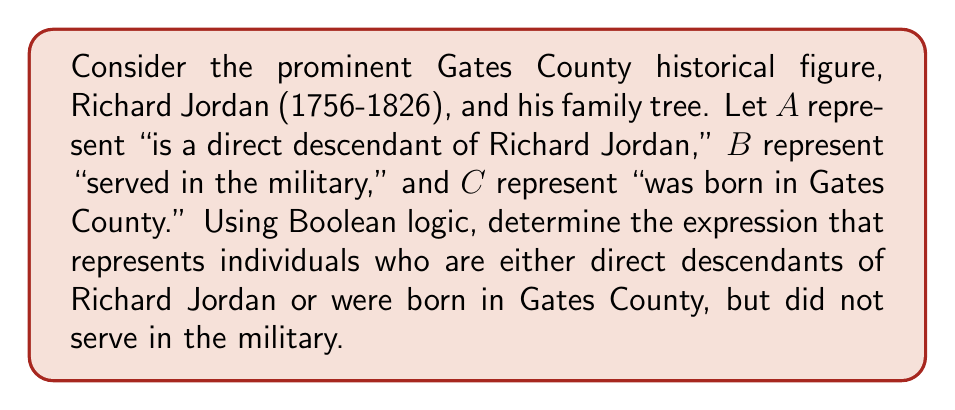What is the answer to this math problem? Let's approach this step-by-step using Boolean algebra:

1) First, we need to identify the basic propositions:
   A: is a direct descendant of Richard Jordan
   B: served in the military
   C: was born in Gates County

2) The question asks for individuals who are either direct descendants of Richard Jordan OR were born in Gates County. In Boolean algebra, this is represented by the OR operation (∨):

   $A ∨ C$

3) However, we also need to exclude those who served in the military. This means we want the negation of B, which is represented by $\overline{B}$ or $¬B$.

4) To combine these conditions, we use the AND operation (∧):

   $(A ∨ C) ∧ \overline{B}$

5) This expression can be expanded using the distributive property:

   $(A ∧ \overline{B}) ∨ (C ∧ \overline{B})$

This final expression represents individuals who are either:
- Direct descendants of Richard Jordan AND did not serve in the military, OR
- Born in Gates County AND did not serve in the military
Answer: $(A ∨ C) ∧ \overline{B}$ 